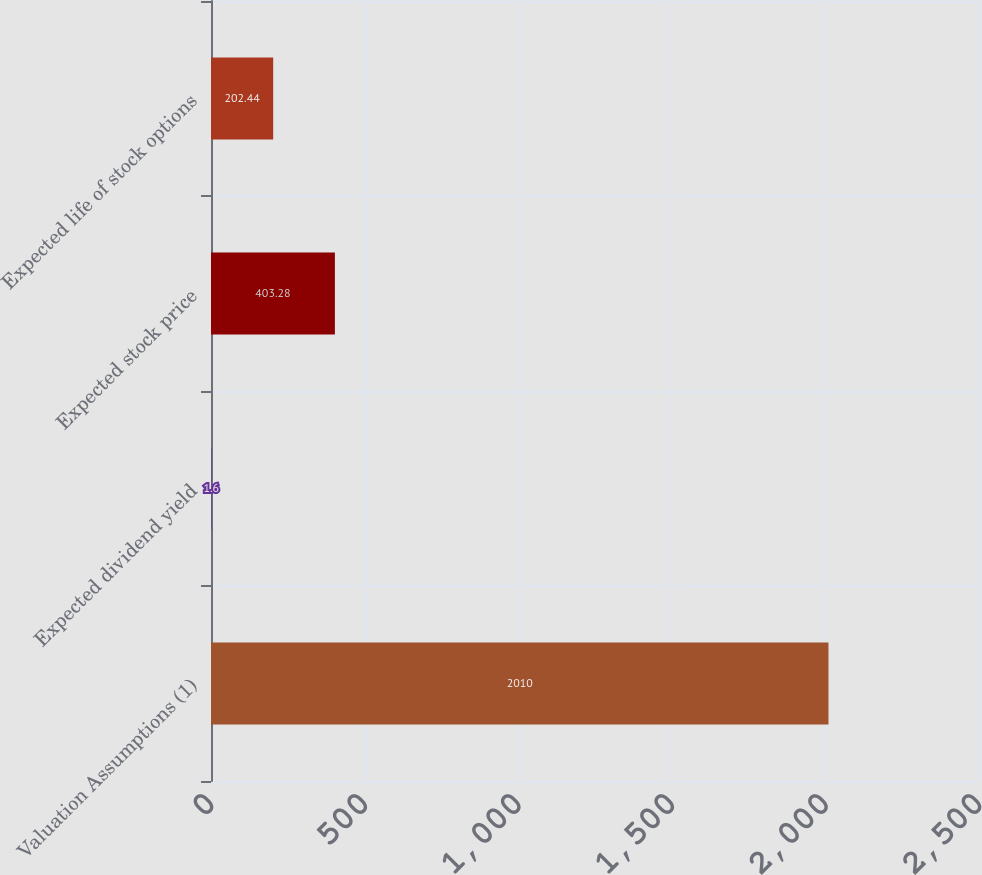Convert chart to OTSL. <chart><loc_0><loc_0><loc_500><loc_500><bar_chart><fcel>Valuation Assumptions (1)<fcel>Expected dividend yield<fcel>Expected stock price<fcel>Expected life of stock options<nl><fcel>2010<fcel>1.6<fcel>403.28<fcel>202.44<nl></chart> 